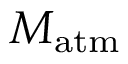<formula> <loc_0><loc_0><loc_500><loc_500>M _ { a t m }</formula> 